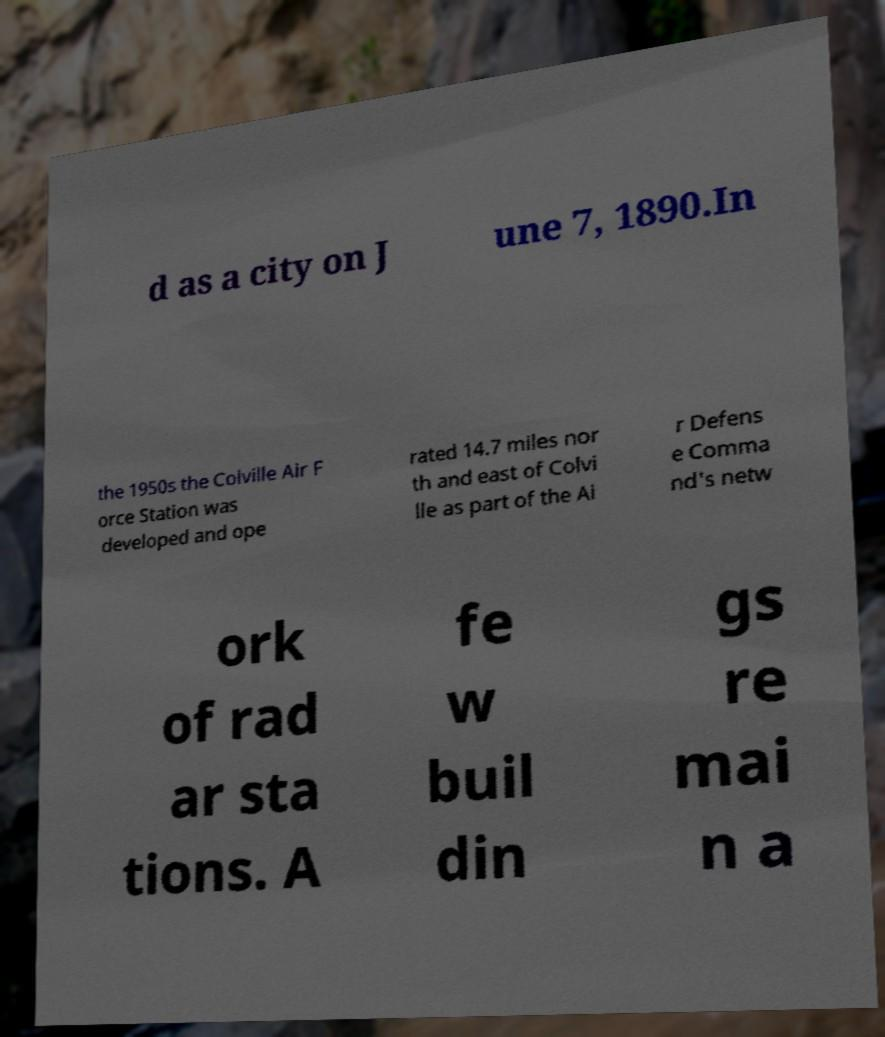Please read and relay the text visible in this image. What does it say? d as a city on J une 7, 1890.In the 1950s the Colville Air F orce Station was developed and ope rated 14.7 miles nor th and east of Colvi lle as part of the Ai r Defens e Comma nd's netw ork of rad ar sta tions. A fe w buil din gs re mai n a 